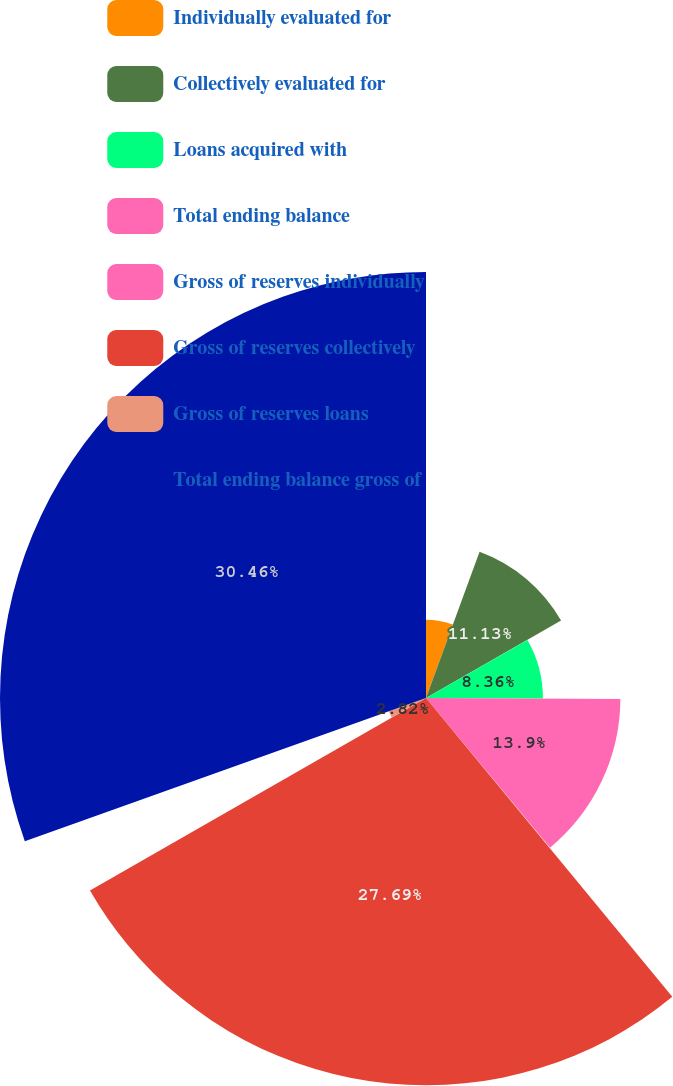Convert chart. <chart><loc_0><loc_0><loc_500><loc_500><pie_chart><fcel>Individually evaluated for<fcel>Collectively evaluated for<fcel>Loans acquired with<fcel>Total ending balance<fcel>Gross of reserves individually<fcel>Gross of reserves collectively<fcel>Gross of reserves loans<fcel>Total ending balance gross of<nl><fcel>5.59%<fcel>11.13%<fcel>8.36%<fcel>13.9%<fcel>0.05%<fcel>27.69%<fcel>2.82%<fcel>30.46%<nl></chart> 